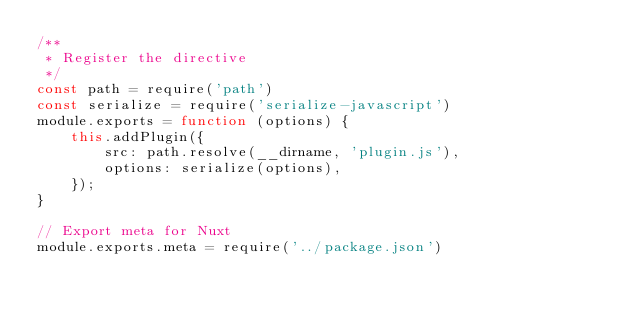<code> <loc_0><loc_0><loc_500><loc_500><_JavaScript_>/**
 * Register the directive
 */
const path = require('path')
const serialize = require('serialize-javascript')
module.exports = function (options) {
	this.addPlugin({
		src: path.resolve(__dirname, 'plugin.js'),
		options: serialize(options),
	});
}

// Export meta for Nuxt
module.exports.meta = require('../package.json')
</code> 